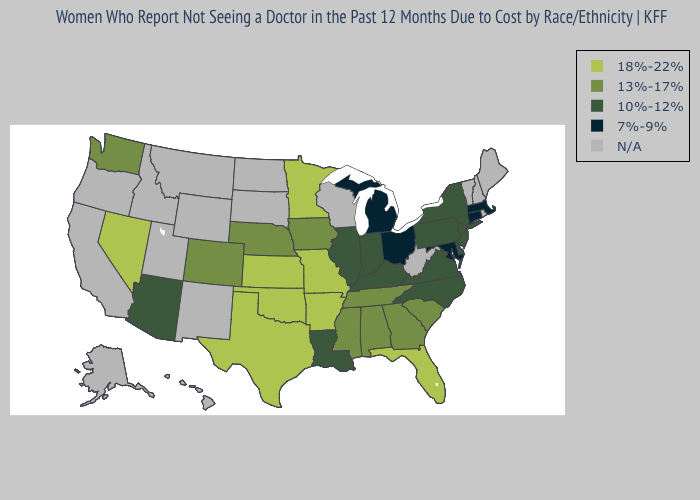What is the value of Kansas?
Answer briefly. 18%-22%. Name the states that have a value in the range 10%-12%?
Keep it brief. Arizona, Delaware, Illinois, Indiana, Kentucky, Louisiana, New Jersey, New York, North Carolina, Pennsylvania, Virginia. Does Minnesota have the highest value in the MidWest?
Quick response, please. Yes. Does Tennessee have the highest value in the South?
Short answer required. No. What is the lowest value in the USA?
Keep it brief. 7%-9%. Does Massachusetts have the lowest value in the Northeast?
Write a very short answer. Yes. What is the value of Florida?
Be succinct. 18%-22%. Name the states that have a value in the range 18%-22%?
Short answer required. Arkansas, Florida, Kansas, Minnesota, Missouri, Nevada, Oklahoma, Texas. Does Michigan have the highest value in the MidWest?
Concise answer only. No. Which states have the highest value in the USA?
Quick response, please. Arkansas, Florida, Kansas, Minnesota, Missouri, Nevada, Oklahoma, Texas. Among the states that border Vermont , which have the highest value?
Quick response, please. New York. Among the states that border Kentucky , does Missouri have the highest value?
Concise answer only. Yes. Which states hav the highest value in the West?
Be succinct. Nevada. What is the value of West Virginia?
Write a very short answer. N/A. 